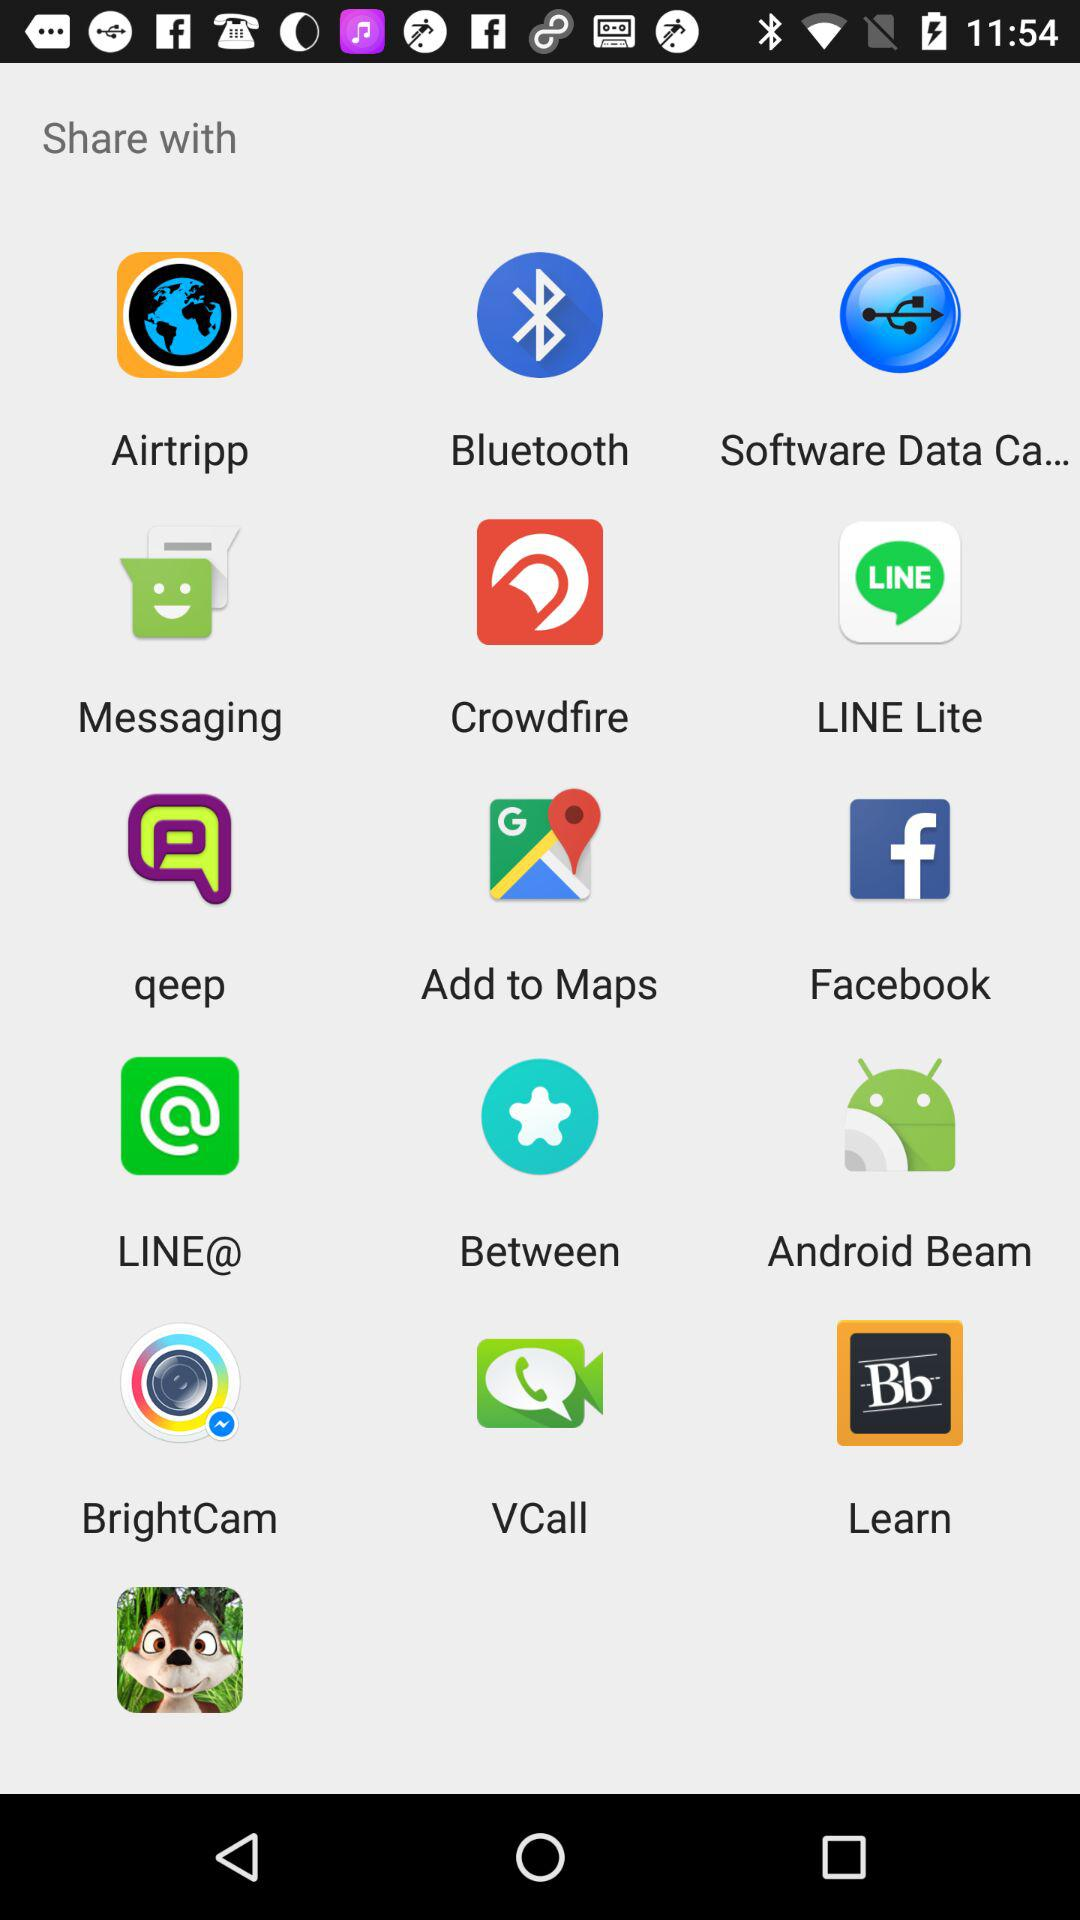Which applications can be used to share? The applications that can be used to share are "Airtripp", "Bluetooth", "Software Data Ca...", "Messaging", "Crowdfire", "LINE Lite", "qeep", "Add to Maps", "Facebook", "LINE@", "Between", "Android Beam", "BrightCam", "VCall" and "VCall". 